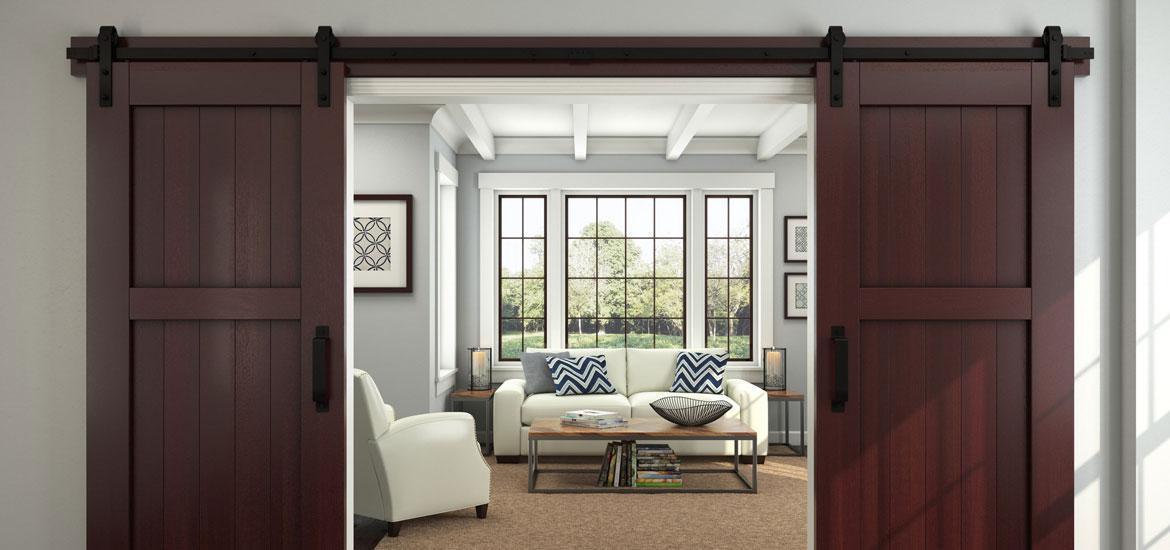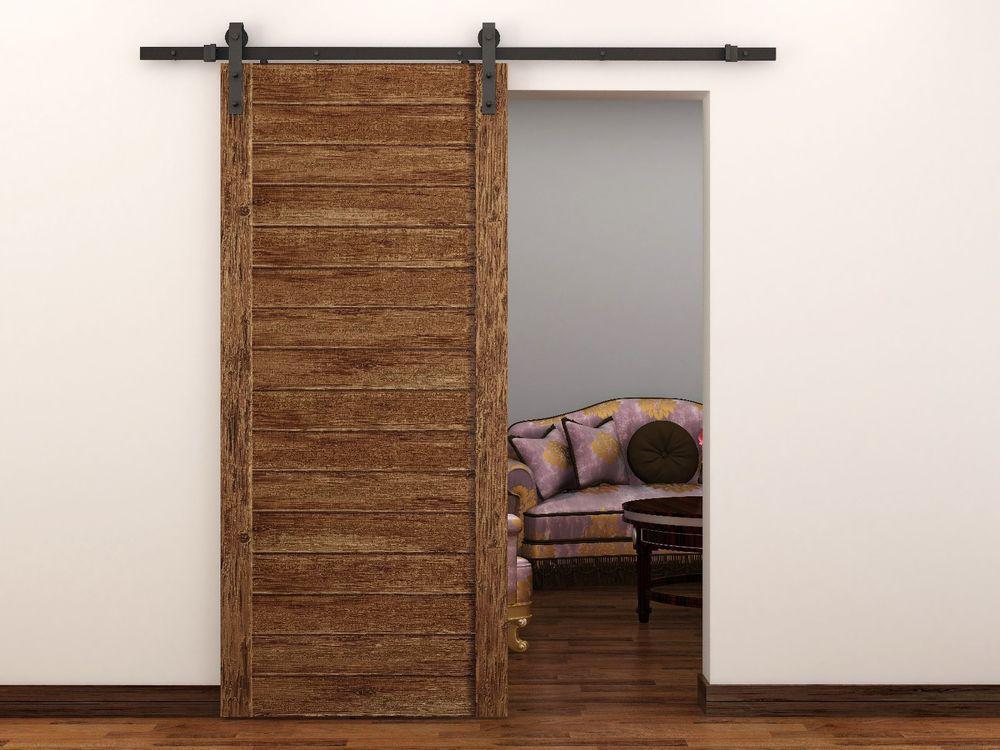The first image is the image on the left, the second image is the image on the right. Considering the images on both sides, is "The left and right image contains the same number of hanging doors made of solid wood." valid? Answer yes or no. No. The first image is the image on the left, the second image is the image on the right. Analyze the images presented: Is the assertion "The right image shows a sliding door to the left of the dooorway." valid? Answer yes or no. Yes. 